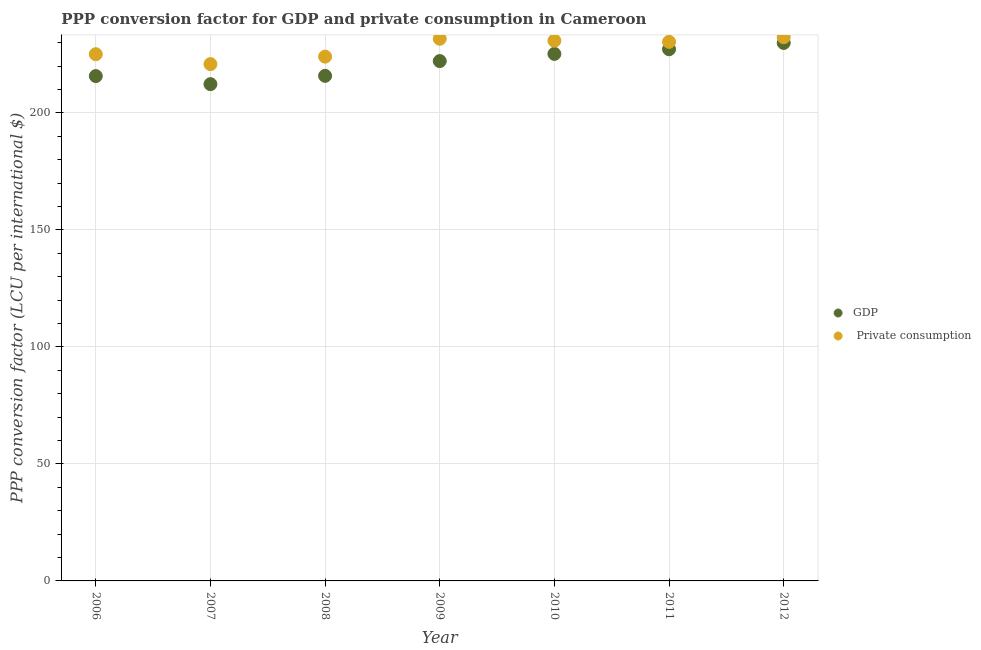Is the number of dotlines equal to the number of legend labels?
Make the answer very short. Yes. What is the ppp conversion factor for gdp in 2009?
Keep it short and to the point. 222.15. Across all years, what is the maximum ppp conversion factor for gdp?
Make the answer very short. 229.9. Across all years, what is the minimum ppp conversion factor for private consumption?
Provide a short and direct response. 220.86. In which year was the ppp conversion factor for gdp minimum?
Provide a short and direct response. 2007. What is the total ppp conversion factor for private consumption in the graph?
Offer a very short reply. 1595.27. What is the difference between the ppp conversion factor for gdp in 2009 and that in 2011?
Offer a very short reply. -5.06. What is the difference between the ppp conversion factor for gdp in 2012 and the ppp conversion factor for private consumption in 2008?
Your answer should be compact. 5.85. What is the average ppp conversion factor for gdp per year?
Your answer should be very brief. 221.19. In the year 2012, what is the difference between the ppp conversion factor for private consumption and ppp conversion factor for gdp?
Provide a short and direct response. 2.45. In how many years, is the ppp conversion factor for gdp greater than 40 LCU?
Make the answer very short. 7. What is the ratio of the ppp conversion factor for private consumption in 2008 to that in 2012?
Offer a very short reply. 0.96. What is the difference between the highest and the second highest ppp conversion factor for private consumption?
Offer a very short reply. 0.65. What is the difference between the highest and the lowest ppp conversion factor for gdp?
Your answer should be compact. 17.6. Is the ppp conversion factor for gdp strictly greater than the ppp conversion factor for private consumption over the years?
Ensure brevity in your answer.  No. How many dotlines are there?
Your answer should be compact. 2. How many years are there in the graph?
Ensure brevity in your answer.  7. Does the graph contain grids?
Provide a short and direct response. Yes. Where does the legend appear in the graph?
Offer a very short reply. Center right. How are the legend labels stacked?
Offer a terse response. Vertical. What is the title of the graph?
Offer a terse response. PPP conversion factor for GDP and private consumption in Cameroon. Does "Residents" appear as one of the legend labels in the graph?
Offer a very short reply. No. What is the label or title of the Y-axis?
Offer a terse response. PPP conversion factor (LCU per international $). What is the PPP conversion factor (LCU per international $) in GDP in 2006?
Make the answer very short. 215.74. What is the PPP conversion factor (LCU per international $) of  Private consumption in 2006?
Make the answer very short. 225.09. What is the PPP conversion factor (LCU per international $) in GDP in 2007?
Keep it short and to the point. 212.29. What is the PPP conversion factor (LCU per international $) in  Private consumption in 2007?
Make the answer very short. 220.86. What is the PPP conversion factor (LCU per international $) in GDP in 2008?
Keep it short and to the point. 215.84. What is the PPP conversion factor (LCU per international $) of  Private consumption in 2008?
Offer a very short reply. 224.05. What is the PPP conversion factor (LCU per international $) in GDP in 2009?
Provide a succinct answer. 222.15. What is the PPP conversion factor (LCU per international $) in  Private consumption in 2009?
Offer a terse response. 231.69. What is the PPP conversion factor (LCU per international $) of GDP in 2010?
Your answer should be compact. 225.22. What is the PPP conversion factor (LCU per international $) of  Private consumption in 2010?
Keep it short and to the point. 230.86. What is the PPP conversion factor (LCU per international $) in GDP in 2011?
Ensure brevity in your answer.  227.21. What is the PPP conversion factor (LCU per international $) of  Private consumption in 2011?
Your response must be concise. 230.38. What is the PPP conversion factor (LCU per international $) in GDP in 2012?
Keep it short and to the point. 229.9. What is the PPP conversion factor (LCU per international $) of  Private consumption in 2012?
Offer a terse response. 232.35. Across all years, what is the maximum PPP conversion factor (LCU per international $) in GDP?
Provide a short and direct response. 229.9. Across all years, what is the maximum PPP conversion factor (LCU per international $) of  Private consumption?
Make the answer very short. 232.35. Across all years, what is the minimum PPP conversion factor (LCU per international $) of GDP?
Give a very brief answer. 212.29. Across all years, what is the minimum PPP conversion factor (LCU per international $) in  Private consumption?
Offer a very short reply. 220.86. What is the total PPP conversion factor (LCU per international $) of GDP in the graph?
Your answer should be compact. 1548.35. What is the total PPP conversion factor (LCU per international $) in  Private consumption in the graph?
Your answer should be very brief. 1595.27. What is the difference between the PPP conversion factor (LCU per international $) of GDP in 2006 and that in 2007?
Your answer should be very brief. 3.44. What is the difference between the PPP conversion factor (LCU per international $) of  Private consumption in 2006 and that in 2007?
Make the answer very short. 4.23. What is the difference between the PPP conversion factor (LCU per international $) of GDP in 2006 and that in 2008?
Ensure brevity in your answer.  -0.1. What is the difference between the PPP conversion factor (LCU per international $) in  Private consumption in 2006 and that in 2008?
Provide a succinct answer. 1.04. What is the difference between the PPP conversion factor (LCU per international $) in GDP in 2006 and that in 2009?
Offer a very short reply. -6.42. What is the difference between the PPP conversion factor (LCU per international $) of  Private consumption in 2006 and that in 2009?
Ensure brevity in your answer.  -6.6. What is the difference between the PPP conversion factor (LCU per international $) in GDP in 2006 and that in 2010?
Ensure brevity in your answer.  -9.48. What is the difference between the PPP conversion factor (LCU per international $) in  Private consumption in 2006 and that in 2010?
Your answer should be compact. -5.77. What is the difference between the PPP conversion factor (LCU per international $) of GDP in 2006 and that in 2011?
Your answer should be very brief. -11.48. What is the difference between the PPP conversion factor (LCU per international $) in  Private consumption in 2006 and that in 2011?
Make the answer very short. -5.29. What is the difference between the PPP conversion factor (LCU per international $) in GDP in 2006 and that in 2012?
Offer a terse response. -14.16. What is the difference between the PPP conversion factor (LCU per international $) in  Private consumption in 2006 and that in 2012?
Your response must be concise. -7.26. What is the difference between the PPP conversion factor (LCU per international $) in GDP in 2007 and that in 2008?
Make the answer very short. -3.54. What is the difference between the PPP conversion factor (LCU per international $) in  Private consumption in 2007 and that in 2008?
Give a very brief answer. -3.19. What is the difference between the PPP conversion factor (LCU per international $) of GDP in 2007 and that in 2009?
Give a very brief answer. -9.86. What is the difference between the PPP conversion factor (LCU per international $) of  Private consumption in 2007 and that in 2009?
Ensure brevity in your answer.  -10.83. What is the difference between the PPP conversion factor (LCU per international $) in GDP in 2007 and that in 2010?
Your answer should be compact. -12.93. What is the difference between the PPP conversion factor (LCU per international $) in  Private consumption in 2007 and that in 2010?
Provide a succinct answer. -10. What is the difference between the PPP conversion factor (LCU per international $) in GDP in 2007 and that in 2011?
Offer a very short reply. -14.92. What is the difference between the PPP conversion factor (LCU per international $) of  Private consumption in 2007 and that in 2011?
Your answer should be compact. -9.51. What is the difference between the PPP conversion factor (LCU per international $) in GDP in 2007 and that in 2012?
Provide a succinct answer. -17.6. What is the difference between the PPP conversion factor (LCU per international $) in  Private consumption in 2007 and that in 2012?
Your answer should be compact. -11.48. What is the difference between the PPP conversion factor (LCU per international $) of GDP in 2008 and that in 2009?
Make the answer very short. -6.31. What is the difference between the PPP conversion factor (LCU per international $) in  Private consumption in 2008 and that in 2009?
Your answer should be very brief. -7.64. What is the difference between the PPP conversion factor (LCU per international $) of GDP in 2008 and that in 2010?
Your answer should be compact. -9.38. What is the difference between the PPP conversion factor (LCU per international $) in  Private consumption in 2008 and that in 2010?
Provide a succinct answer. -6.81. What is the difference between the PPP conversion factor (LCU per international $) in GDP in 2008 and that in 2011?
Offer a terse response. -11.37. What is the difference between the PPP conversion factor (LCU per international $) in  Private consumption in 2008 and that in 2011?
Keep it short and to the point. -6.33. What is the difference between the PPP conversion factor (LCU per international $) in GDP in 2008 and that in 2012?
Offer a very short reply. -14.06. What is the difference between the PPP conversion factor (LCU per international $) of  Private consumption in 2008 and that in 2012?
Your answer should be compact. -8.3. What is the difference between the PPP conversion factor (LCU per international $) of GDP in 2009 and that in 2010?
Provide a succinct answer. -3.07. What is the difference between the PPP conversion factor (LCU per international $) in  Private consumption in 2009 and that in 2010?
Your answer should be compact. 0.83. What is the difference between the PPP conversion factor (LCU per international $) in GDP in 2009 and that in 2011?
Your answer should be very brief. -5.06. What is the difference between the PPP conversion factor (LCU per international $) of  Private consumption in 2009 and that in 2011?
Your answer should be very brief. 1.32. What is the difference between the PPP conversion factor (LCU per international $) in GDP in 2009 and that in 2012?
Your response must be concise. -7.74. What is the difference between the PPP conversion factor (LCU per international $) of  Private consumption in 2009 and that in 2012?
Your answer should be compact. -0.65. What is the difference between the PPP conversion factor (LCU per international $) in GDP in 2010 and that in 2011?
Offer a terse response. -1.99. What is the difference between the PPP conversion factor (LCU per international $) in  Private consumption in 2010 and that in 2011?
Make the answer very short. 0.49. What is the difference between the PPP conversion factor (LCU per international $) in GDP in 2010 and that in 2012?
Offer a terse response. -4.68. What is the difference between the PPP conversion factor (LCU per international $) in  Private consumption in 2010 and that in 2012?
Make the answer very short. -1.48. What is the difference between the PPP conversion factor (LCU per international $) of GDP in 2011 and that in 2012?
Your answer should be very brief. -2.68. What is the difference between the PPP conversion factor (LCU per international $) of  Private consumption in 2011 and that in 2012?
Provide a short and direct response. -1.97. What is the difference between the PPP conversion factor (LCU per international $) of GDP in 2006 and the PPP conversion factor (LCU per international $) of  Private consumption in 2007?
Provide a short and direct response. -5.13. What is the difference between the PPP conversion factor (LCU per international $) of GDP in 2006 and the PPP conversion factor (LCU per international $) of  Private consumption in 2008?
Provide a succinct answer. -8.31. What is the difference between the PPP conversion factor (LCU per international $) in GDP in 2006 and the PPP conversion factor (LCU per international $) in  Private consumption in 2009?
Your answer should be compact. -15.96. What is the difference between the PPP conversion factor (LCU per international $) in GDP in 2006 and the PPP conversion factor (LCU per international $) in  Private consumption in 2010?
Give a very brief answer. -15.12. What is the difference between the PPP conversion factor (LCU per international $) in GDP in 2006 and the PPP conversion factor (LCU per international $) in  Private consumption in 2011?
Your answer should be very brief. -14.64. What is the difference between the PPP conversion factor (LCU per international $) of GDP in 2006 and the PPP conversion factor (LCU per international $) of  Private consumption in 2012?
Offer a terse response. -16.61. What is the difference between the PPP conversion factor (LCU per international $) in GDP in 2007 and the PPP conversion factor (LCU per international $) in  Private consumption in 2008?
Provide a short and direct response. -11.76. What is the difference between the PPP conversion factor (LCU per international $) of GDP in 2007 and the PPP conversion factor (LCU per international $) of  Private consumption in 2009?
Your answer should be very brief. -19.4. What is the difference between the PPP conversion factor (LCU per international $) of GDP in 2007 and the PPP conversion factor (LCU per international $) of  Private consumption in 2010?
Provide a short and direct response. -18.57. What is the difference between the PPP conversion factor (LCU per international $) in GDP in 2007 and the PPP conversion factor (LCU per international $) in  Private consumption in 2011?
Ensure brevity in your answer.  -18.08. What is the difference between the PPP conversion factor (LCU per international $) of GDP in 2007 and the PPP conversion factor (LCU per international $) of  Private consumption in 2012?
Offer a very short reply. -20.05. What is the difference between the PPP conversion factor (LCU per international $) in GDP in 2008 and the PPP conversion factor (LCU per international $) in  Private consumption in 2009?
Give a very brief answer. -15.85. What is the difference between the PPP conversion factor (LCU per international $) in GDP in 2008 and the PPP conversion factor (LCU per international $) in  Private consumption in 2010?
Your answer should be compact. -15.02. What is the difference between the PPP conversion factor (LCU per international $) in GDP in 2008 and the PPP conversion factor (LCU per international $) in  Private consumption in 2011?
Your response must be concise. -14.54. What is the difference between the PPP conversion factor (LCU per international $) in GDP in 2008 and the PPP conversion factor (LCU per international $) in  Private consumption in 2012?
Provide a succinct answer. -16.51. What is the difference between the PPP conversion factor (LCU per international $) of GDP in 2009 and the PPP conversion factor (LCU per international $) of  Private consumption in 2010?
Give a very brief answer. -8.71. What is the difference between the PPP conversion factor (LCU per international $) in GDP in 2009 and the PPP conversion factor (LCU per international $) in  Private consumption in 2011?
Provide a succinct answer. -8.22. What is the difference between the PPP conversion factor (LCU per international $) of GDP in 2009 and the PPP conversion factor (LCU per international $) of  Private consumption in 2012?
Your response must be concise. -10.19. What is the difference between the PPP conversion factor (LCU per international $) in GDP in 2010 and the PPP conversion factor (LCU per international $) in  Private consumption in 2011?
Ensure brevity in your answer.  -5.16. What is the difference between the PPP conversion factor (LCU per international $) in GDP in 2010 and the PPP conversion factor (LCU per international $) in  Private consumption in 2012?
Your answer should be compact. -7.13. What is the difference between the PPP conversion factor (LCU per international $) in GDP in 2011 and the PPP conversion factor (LCU per international $) in  Private consumption in 2012?
Provide a succinct answer. -5.13. What is the average PPP conversion factor (LCU per international $) of GDP per year?
Provide a short and direct response. 221.19. What is the average PPP conversion factor (LCU per international $) in  Private consumption per year?
Give a very brief answer. 227.9. In the year 2006, what is the difference between the PPP conversion factor (LCU per international $) in GDP and PPP conversion factor (LCU per international $) in  Private consumption?
Offer a terse response. -9.35. In the year 2007, what is the difference between the PPP conversion factor (LCU per international $) in GDP and PPP conversion factor (LCU per international $) in  Private consumption?
Ensure brevity in your answer.  -8.57. In the year 2008, what is the difference between the PPP conversion factor (LCU per international $) of GDP and PPP conversion factor (LCU per international $) of  Private consumption?
Provide a short and direct response. -8.21. In the year 2009, what is the difference between the PPP conversion factor (LCU per international $) of GDP and PPP conversion factor (LCU per international $) of  Private consumption?
Your response must be concise. -9.54. In the year 2010, what is the difference between the PPP conversion factor (LCU per international $) of GDP and PPP conversion factor (LCU per international $) of  Private consumption?
Your answer should be very brief. -5.64. In the year 2011, what is the difference between the PPP conversion factor (LCU per international $) of GDP and PPP conversion factor (LCU per international $) of  Private consumption?
Your answer should be very brief. -3.16. In the year 2012, what is the difference between the PPP conversion factor (LCU per international $) in GDP and PPP conversion factor (LCU per international $) in  Private consumption?
Ensure brevity in your answer.  -2.45. What is the ratio of the PPP conversion factor (LCU per international $) of GDP in 2006 to that in 2007?
Ensure brevity in your answer.  1.02. What is the ratio of the PPP conversion factor (LCU per international $) of  Private consumption in 2006 to that in 2007?
Keep it short and to the point. 1.02. What is the ratio of the PPP conversion factor (LCU per international $) of  Private consumption in 2006 to that in 2008?
Provide a short and direct response. 1. What is the ratio of the PPP conversion factor (LCU per international $) in GDP in 2006 to that in 2009?
Keep it short and to the point. 0.97. What is the ratio of the PPP conversion factor (LCU per international $) of  Private consumption in 2006 to that in 2009?
Your response must be concise. 0.97. What is the ratio of the PPP conversion factor (LCU per international $) in GDP in 2006 to that in 2010?
Keep it short and to the point. 0.96. What is the ratio of the PPP conversion factor (LCU per international $) of GDP in 2006 to that in 2011?
Keep it short and to the point. 0.95. What is the ratio of the PPP conversion factor (LCU per international $) in  Private consumption in 2006 to that in 2011?
Your answer should be compact. 0.98. What is the ratio of the PPP conversion factor (LCU per international $) in GDP in 2006 to that in 2012?
Make the answer very short. 0.94. What is the ratio of the PPP conversion factor (LCU per international $) of  Private consumption in 2006 to that in 2012?
Provide a short and direct response. 0.97. What is the ratio of the PPP conversion factor (LCU per international $) of GDP in 2007 to that in 2008?
Offer a terse response. 0.98. What is the ratio of the PPP conversion factor (LCU per international $) in  Private consumption in 2007 to that in 2008?
Your answer should be very brief. 0.99. What is the ratio of the PPP conversion factor (LCU per international $) in GDP in 2007 to that in 2009?
Your answer should be compact. 0.96. What is the ratio of the PPP conversion factor (LCU per international $) in  Private consumption in 2007 to that in 2009?
Offer a terse response. 0.95. What is the ratio of the PPP conversion factor (LCU per international $) of GDP in 2007 to that in 2010?
Make the answer very short. 0.94. What is the ratio of the PPP conversion factor (LCU per international $) in  Private consumption in 2007 to that in 2010?
Provide a short and direct response. 0.96. What is the ratio of the PPP conversion factor (LCU per international $) in GDP in 2007 to that in 2011?
Give a very brief answer. 0.93. What is the ratio of the PPP conversion factor (LCU per international $) of  Private consumption in 2007 to that in 2011?
Your answer should be compact. 0.96. What is the ratio of the PPP conversion factor (LCU per international $) in GDP in 2007 to that in 2012?
Provide a short and direct response. 0.92. What is the ratio of the PPP conversion factor (LCU per international $) of  Private consumption in 2007 to that in 2012?
Offer a terse response. 0.95. What is the ratio of the PPP conversion factor (LCU per international $) in GDP in 2008 to that in 2009?
Ensure brevity in your answer.  0.97. What is the ratio of the PPP conversion factor (LCU per international $) in GDP in 2008 to that in 2010?
Provide a short and direct response. 0.96. What is the ratio of the PPP conversion factor (LCU per international $) of  Private consumption in 2008 to that in 2010?
Provide a short and direct response. 0.97. What is the ratio of the PPP conversion factor (LCU per international $) in GDP in 2008 to that in 2011?
Provide a succinct answer. 0.95. What is the ratio of the PPP conversion factor (LCU per international $) in  Private consumption in 2008 to that in 2011?
Provide a succinct answer. 0.97. What is the ratio of the PPP conversion factor (LCU per international $) in GDP in 2008 to that in 2012?
Your answer should be compact. 0.94. What is the ratio of the PPP conversion factor (LCU per international $) of GDP in 2009 to that in 2010?
Keep it short and to the point. 0.99. What is the ratio of the PPP conversion factor (LCU per international $) of GDP in 2009 to that in 2011?
Your response must be concise. 0.98. What is the ratio of the PPP conversion factor (LCU per international $) in GDP in 2009 to that in 2012?
Provide a short and direct response. 0.97. What is the ratio of the PPP conversion factor (LCU per international $) of  Private consumption in 2010 to that in 2011?
Your answer should be very brief. 1. What is the ratio of the PPP conversion factor (LCU per international $) in GDP in 2010 to that in 2012?
Your response must be concise. 0.98. What is the ratio of the PPP conversion factor (LCU per international $) of GDP in 2011 to that in 2012?
Keep it short and to the point. 0.99. What is the ratio of the PPP conversion factor (LCU per international $) of  Private consumption in 2011 to that in 2012?
Give a very brief answer. 0.99. What is the difference between the highest and the second highest PPP conversion factor (LCU per international $) of GDP?
Provide a short and direct response. 2.68. What is the difference between the highest and the second highest PPP conversion factor (LCU per international $) in  Private consumption?
Provide a short and direct response. 0.65. What is the difference between the highest and the lowest PPP conversion factor (LCU per international $) of GDP?
Offer a terse response. 17.6. What is the difference between the highest and the lowest PPP conversion factor (LCU per international $) in  Private consumption?
Your response must be concise. 11.48. 